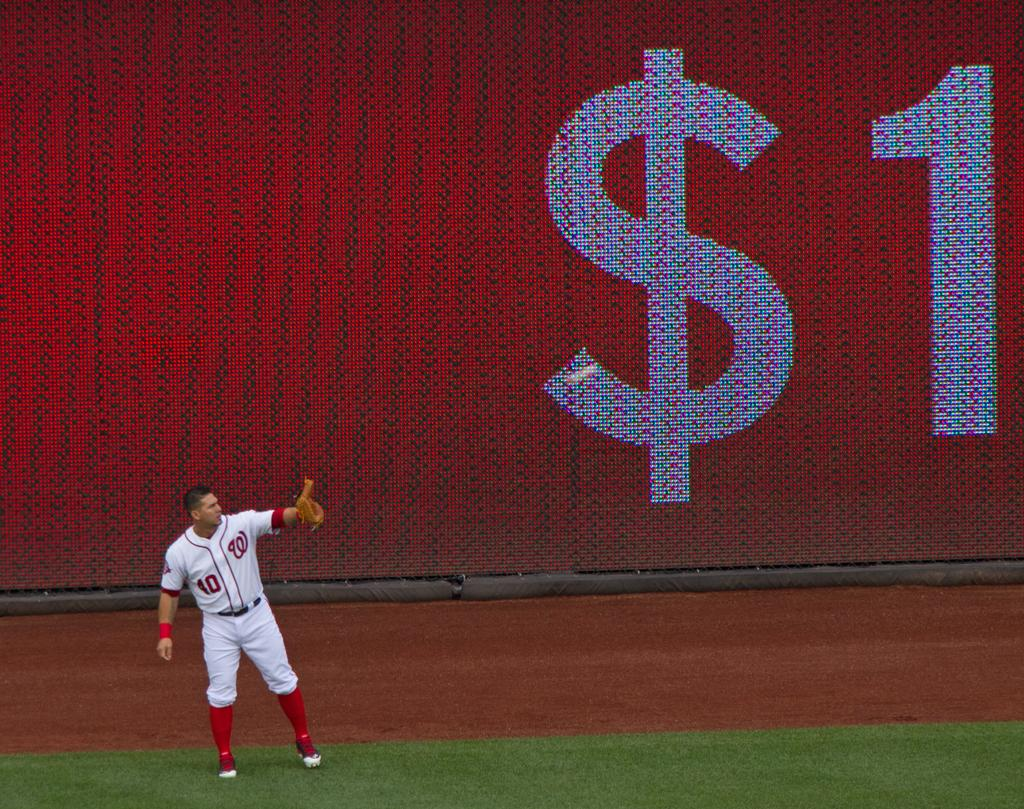<image>
Write a terse but informative summary of the picture. A man wearing a Washington Nationals uniform standing in the outfield in front of a red wall that has $1 printed on it. 